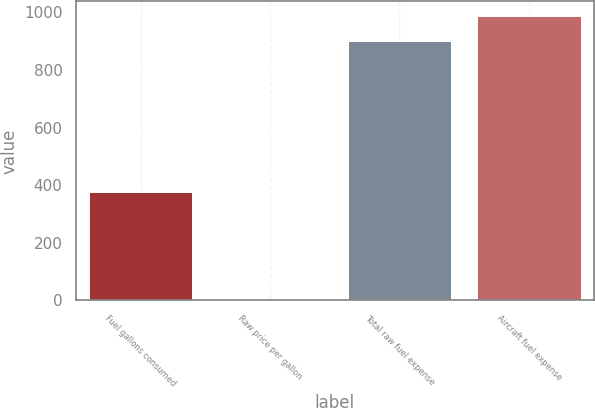Convert chart. <chart><loc_0><loc_0><loc_500><loc_500><bar_chart><fcel>Fuel gallons consumed<fcel>Raw price per gallon<fcel>Total raw fuel expense<fcel>Aircraft fuel expense<nl><fcel>377.3<fcel>2.38<fcel>898.9<fcel>988.75<nl></chart> 